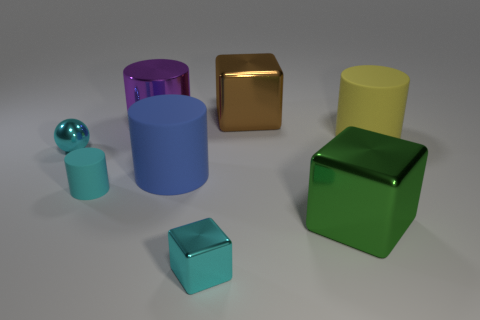There is a object behind the purple shiny thing; does it have the same color as the cylinder that is on the left side of the large purple object?
Offer a very short reply. No. Are there any other things that have the same color as the tiny sphere?
Provide a succinct answer. Yes. The block that is behind the cyan thing that is behind the blue matte cylinder is what color?
Your answer should be compact. Brown. Are there any purple cylinders?
Keep it short and to the point. Yes. What is the color of the small object that is both on the right side of the cyan metal sphere and behind the small cyan metallic block?
Provide a short and direct response. Cyan. There is a rubber object on the right side of the large brown metallic object; is it the same size as the thing left of the cyan rubber thing?
Offer a very short reply. No. What number of other objects are the same size as the yellow cylinder?
Make the answer very short. 4. How many tiny cyan cubes are right of the thing behind the purple thing?
Keep it short and to the point. 0. Is the number of brown blocks in front of the blue object less than the number of yellow cylinders?
Ensure brevity in your answer.  Yes. What is the shape of the tiny metallic object that is behind the big cube in front of the small thing that is behind the cyan matte cylinder?
Your answer should be very brief. Sphere. 